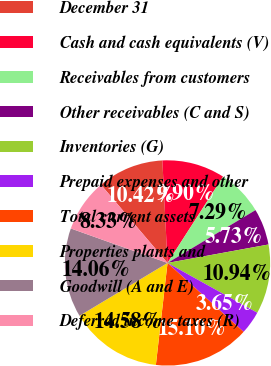<chart> <loc_0><loc_0><loc_500><loc_500><pie_chart><fcel>December 31<fcel>Cash and cash equivalents (V)<fcel>Receivables from customers<fcel>Other receivables (C and S)<fcel>Inventories (G)<fcel>Prepaid expenses and other<fcel>Total current assets<fcel>Properties plants and<fcel>Goodwill (A and E)<fcel>Deferred income taxes (R)<nl><fcel>10.42%<fcel>9.9%<fcel>7.29%<fcel>5.73%<fcel>10.94%<fcel>3.65%<fcel>15.1%<fcel>14.58%<fcel>14.06%<fcel>8.33%<nl></chart> 